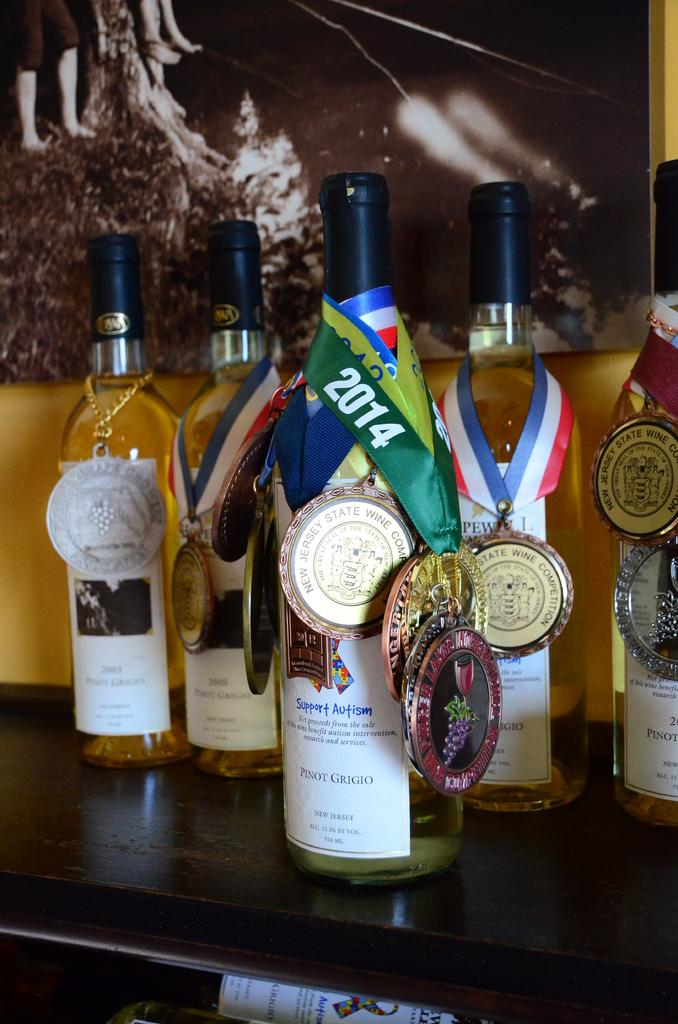<image>
Share a concise interpretation of the image provided. A bottle of Pinot Grigio that supports Autism. 